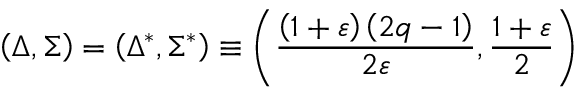<formula> <loc_0><loc_0><loc_500><loc_500>\left ( \Delta , \Sigma \right ) = \left ( \Delta ^ { * } , \Sigma ^ { * } \right ) \equiv \left ( \frac { \left ( 1 + \varepsilon \right ) \left ( 2 q - 1 \right ) } { 2 \varepsilon } , \frac { 1 + \varepsilon } { 2 } \right )</formula> 